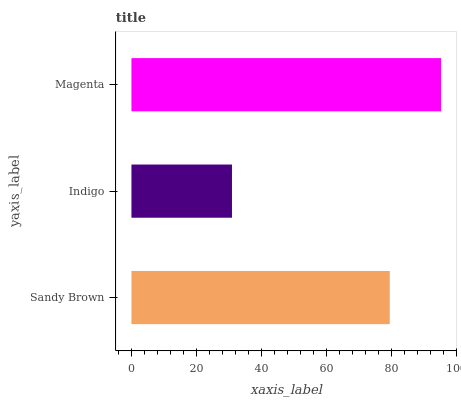Is Indigo the minimum?
Answer yes or no. Yes. Is Magenta the maximum?
Answer yes or no. Yes. Is Magenta the minimum?
Answer yes or no. No. Is Indigo the maximum?
Answer yes or no. No. Is Magenta greater than Indigo?
Answer yes or no. Yes. Is Indigo less than Magenta?
Answer yes or no. Yes. Is Indigo greater than Magenta?
Answer yes or no. No. Is Magenta less than Indigo?
Answer yes or no. No. Is Sandy Brown the high median?
Answer yes or no. Yes. Is Sandy Brown the low median?
Answer yes or no. Yes. Is Magenta the high median?
Answer yes or no. No. Is Indigo the low median?
Answer yes or no. No. 